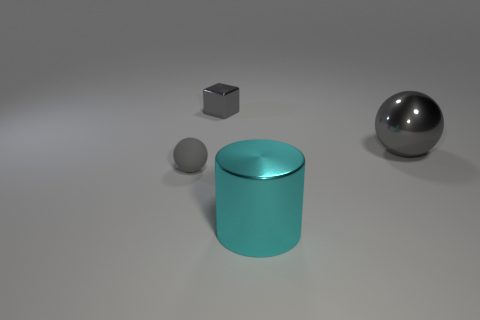What number of other things are there of the same color as the large sphere?
Make the answer very short. 2. How many tiny objects are made of the same material as the cylinder?
Your answer should be compact. 1. What number of things are either large red matte objects or cylinders?
Offer a terse response. 1. Are any big gray metallic blocks visible?
Offer a very short reply. No. What material is the thing behind the metal ball that is behind the big metallic thing in front of the gray rubber object?
Give a very brief answer. Metal. Is the number of large shiny spheres in front of the tiny sphere less than the number of cyan metallic things?
Your answer should be compact. Yes. There is a cylinder that is the same size as the gray metallic ball; what is its material?
Your answer should be compact. Metal. There is a metallic thing that is both in front of the tiny gray metal cube and left of the large gray sphere; what is its size?
Keep it short and to the point. Large. There is another matte object that is the same shape as the large gray thing; what size is it?
Provide a short and direct response. Small. How many objects are metallic blocks or gray metallic things on the right side of the metal cylinder?
Give a very brief answer. 2. 